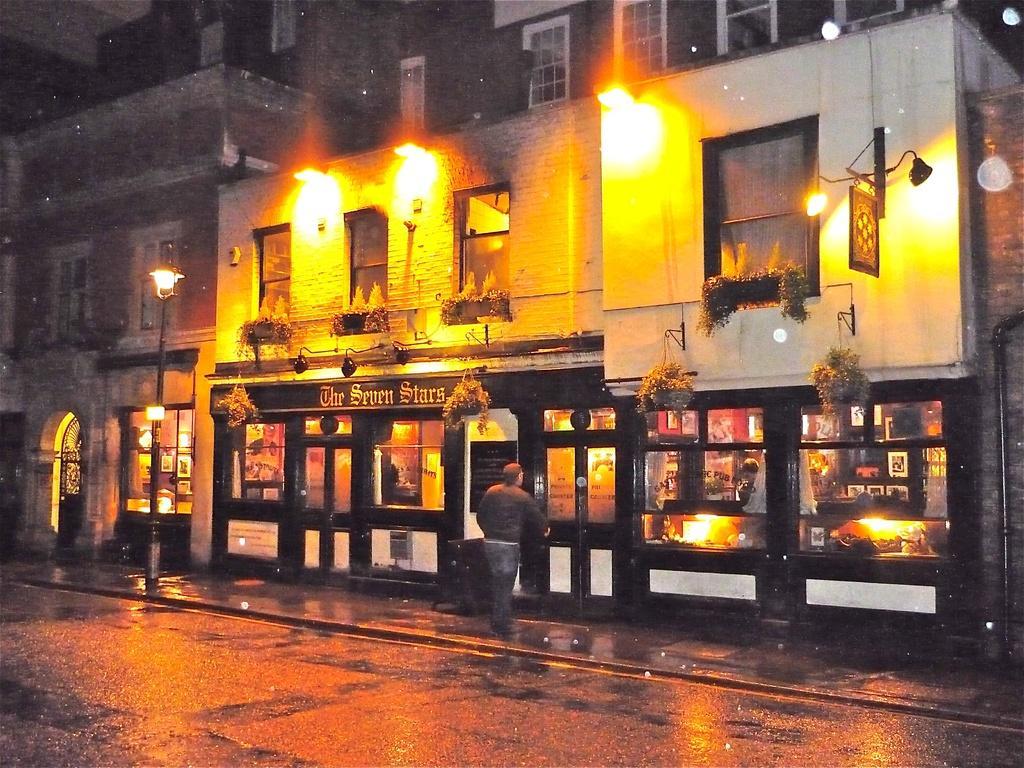How would you summarize this image in a sentence or two? In the foreground of this image, at the bottom, there is the road. In the middle, there are lights, buildings, plants and a man on the side path. 